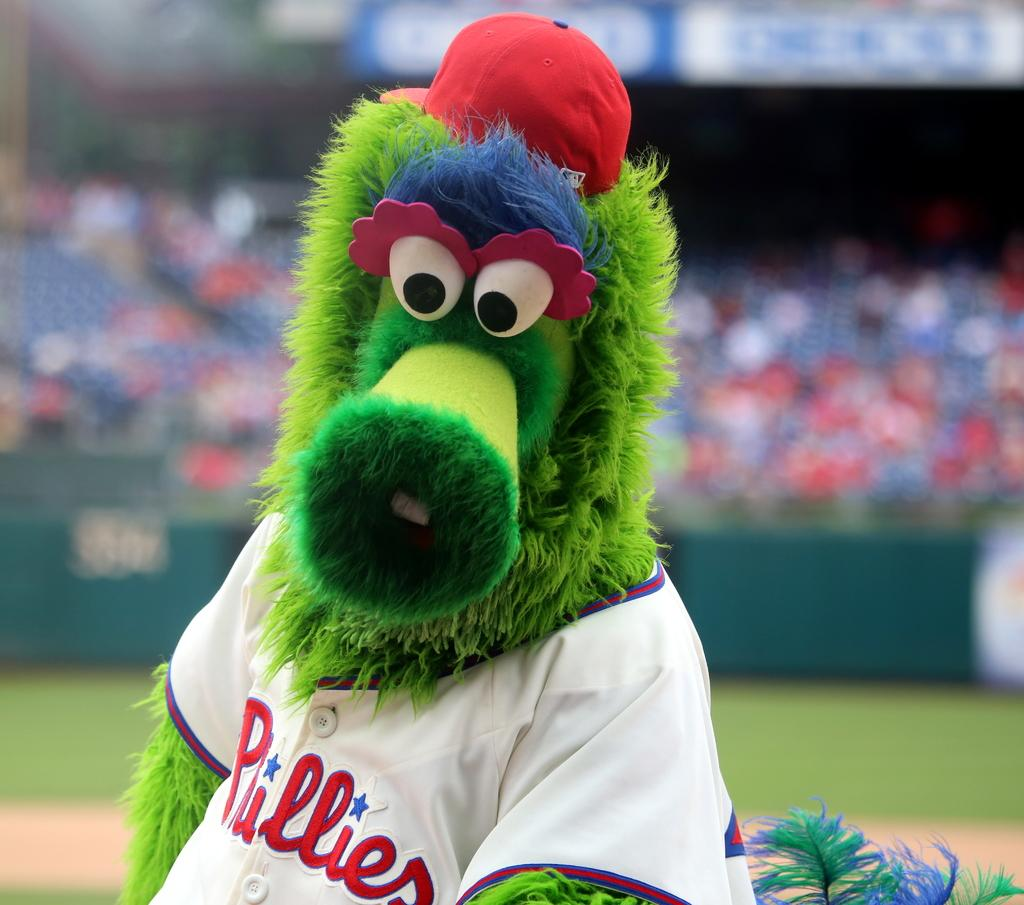<image>
Relay a brief, clear account of the picture shown. a furry green mascot with a jersey that says Phillies on it 